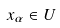Convert formula to latex. <formula><loc_0><loc_0><loc_500><loc_500>x _ { \alpha } \in U</formula> 